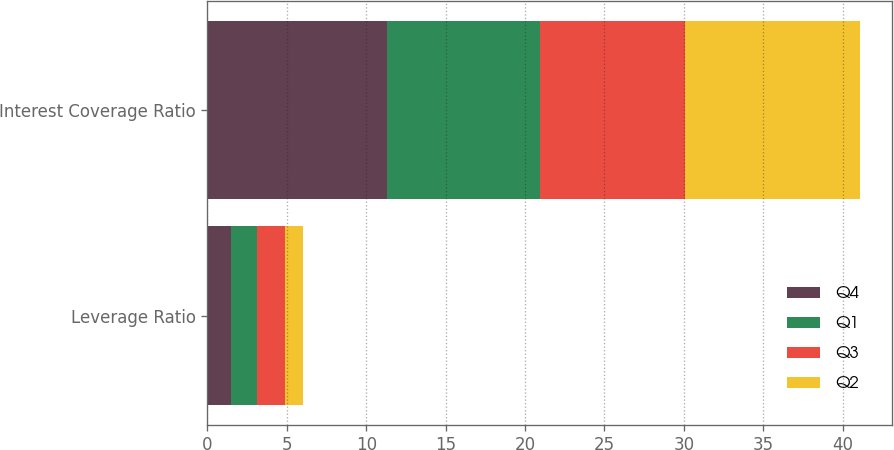Convert chart to OTSL. <chart><loc_0><loc_0><loc_500><loc_500><stacked_bar_chart><ecel><fcel>Leverage Ratio<fcel>Interest Coverage Ratio<nl><fcel>Q4<fcel>1.48<fcel>11.31<nl><fcel>Q1<fcel>1.63<fcel>9.64<nl><fcel>Q3<fcel>1.77<fcel>9.12<nl><fcel>Q2<fcel>1.11<fcel>11.01<nl></chart> 